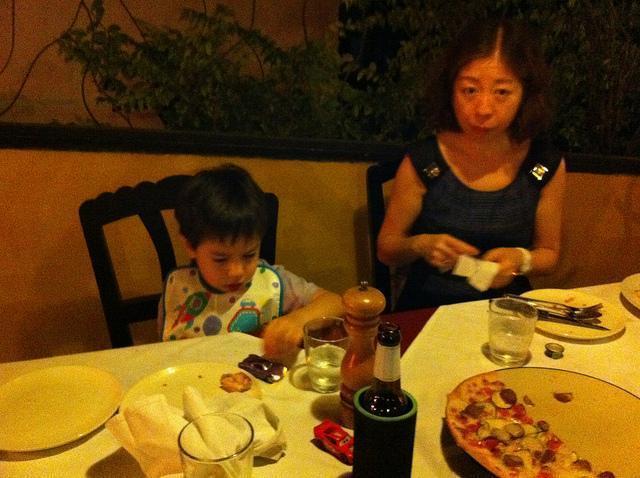How many chairs are there?
Give a very brief answer. 2. How many people are in the photo?
Give a very brief answer. 2. How many cups are in the picture?
Give a very brief answer. 4. How many teddy bears are in the image?
Give a very brief answer. 0. 